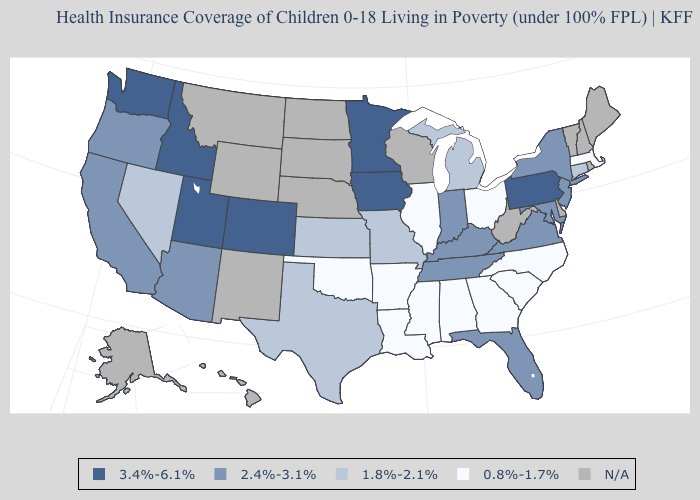What is the value of Idaho?
Give a very brief answer. 3.4%-6.1%. Name the states that have a value in the range 0.8%-1.7%?
Give a very brief answer. Alabama, Arkansas, Georgia, Illinois, Louisiana, Massachusetts, Mississippi, North Carolina, Ohio, Oklahoma, South Carolina. Which states hav the highest value in the MidWest?
Write a very short answer. Iowa, Minnesota. Does the first symbol in the legend represent the smallest category?
Concise answer only. No. Name the states that have a value in the range N/A?
Quick response, please. Alaska, Delaware, Hawaii, Maine, Montana, Nebraska, New Hampshire, New Mexico, North Dakota, Rhode Island, South Dakota, Vermont, West Virginia, Wisconsin, Wyoming. Does Nevada have the lowest value in the West?
Write a very short answer. Yes. Name the states that have a value in the range 0.8%-1.7%?
Concise answer only. Alabama, Arkansas, Georgia, Illinois, Louisiana, Massachusetts, Mississippi, North Carolina, Ohio, Oklahoma, South Carolina. Name the states that have a value in the range 0.8%-1.7%?
Concise answer only. Alabama, Arkansas, Georgia, Illinois, Louisiana, Massachusetts, Mississippi, North Carolina, Ohio, Oklahoma, South Carolina. Which states have the highest value in the USA?
Keep it brief. Colorado, Idaho, Iowa, Minnesota, Pennsylvania, Utah, Washington. Name the states that have a value in the range 2.4%-3.1%?
Write a very short answer. Arizona, California, Florida, Indiana, Kentucky, Maryland, New Jersey, New York, Oregon, Tennessee, Virginia. Among the states that border New York , which have the highest value?
Keep it brief. Pennsylvania. Among the states that border North Dakota , which have the lowest value?
Short answer required. Minnesota. What is the highest value in the MidWest ?
Short answer required. 3.4%-6.1%. Does Kansas have the lowest value in the MidWest?
Write a very short answer. No. What is the lowest value in the USA?
Short answer required. 0.8%-1.7%. 